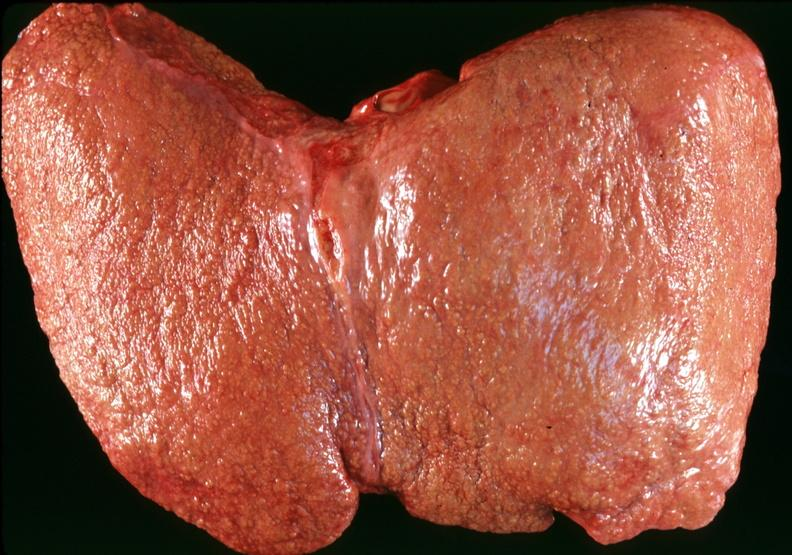what is present?
Answer the question using a single word or phrase. Liver 